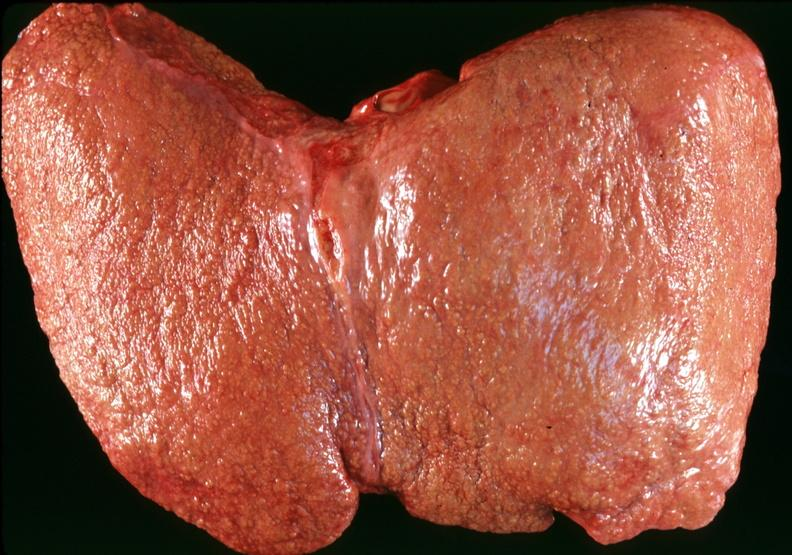what is present?
Answer the question using a single word or phrase. Liver 